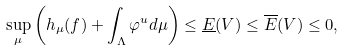Convert formula to latex. <formula><loc_0><loc_0><loc_500><loc_500>\sup _ { \mu } \left ( h _ { \mu } ( f ) + \int _ { \Lambda } \varphi ^ { u } d \mu \right ) \leq \underline { E } ( V ) \leq \overline { E } ( V ) \leq 0 ,</formula> 